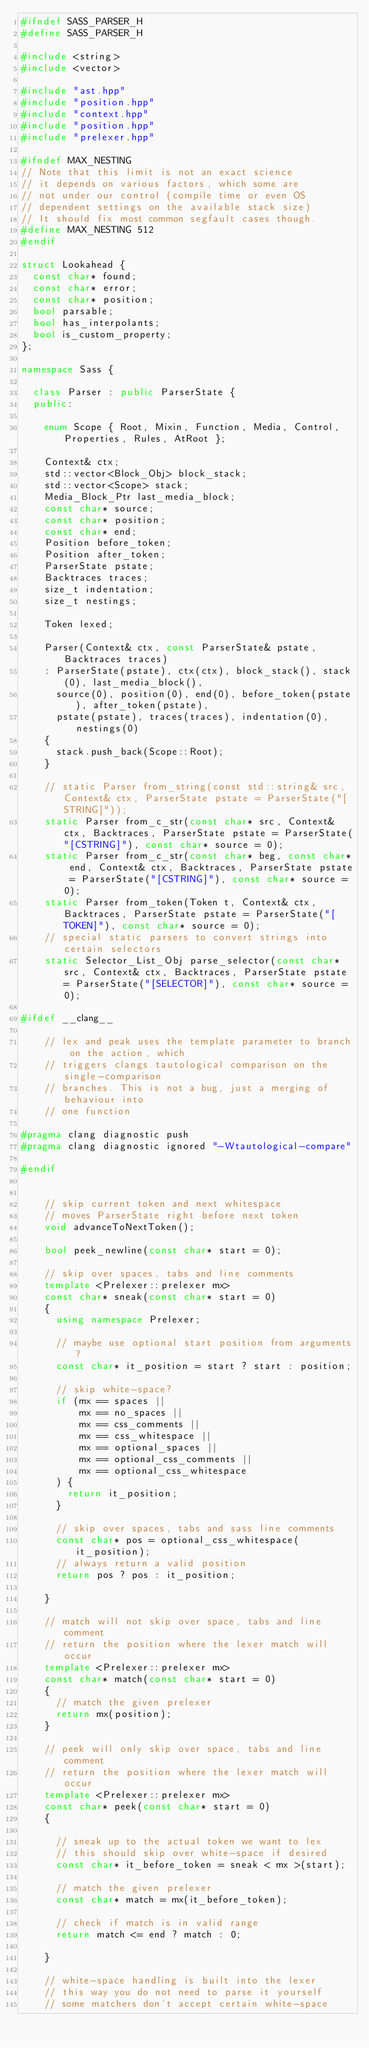Convert code to text. <code><loc_0><loc_0><loc_500><loc_500><_C++_>#ifndef SASS_PARSER_H
#define SASS_PARSER_H

#include <string>
#include <vector>

#include "ast.hpp"
#include "position.hpp"
#include "context.hpp"
#include "position.hpp"
#include "prelexer.hpp"

#ifndef MAX_NESTING
// Note that this limit is not an exact science
// it depends on various factors, which some are
// not under our control (compile time or even OS
// dependent settings on the available stack size)
// It should fix most common segfault cases though.
#define MAX_NESTING 512
#endif

struct Lookahead {
  const char* found;
  const char* error;
  const char* position;
  bool parsable;
  bool has_interpolants;
  bool is_custom_property;
};

namespace Sass {

  class Parser : public ParserState {
  public:

    enum Scope { Root, Mixin, Function, Media, Control, Properties, Rules, AtRoot };

    Context& ctx;
    std::vector<Block_Obj> block_stack;
    std::vector<Scope> stack;
    Media_Block_Ptr last_media_block;
    const char* source;
    const char* position;
    const char* end;
    Position before_token;
    Position after_token;
    ParserState pstate;
    Backtraces traces;
    size_t indentation;
    size_t nestings;

    Token lexed;

    Parser(Context& ctx, const ParserState& pstate, Backtraces traces)
    : ParserState(pstate), ctx(ctx), block_stack(), stack(0), last_media_block(),
      source(0), position(0), end(0), before_token(pstate), after_token(pstate),
      pstate(pstate), traces(traces), indentation(0), nestings(0)
    { 
      stack.push_back(Scope::Root);
    }

    // static Parser from_string(const std::string& src, Context& ctx, ParserState pstate = ParserState("[STRING]"));
    static Parser from_c_str(const char* src, Context& ctx, Backtraces, ParserState pstate = ParserState("[CSTRING]"), const char* source = 0);
    static Parser from_c_str(const char* beg, const char* end, Context& ctx, Backtraces, ParserState pstate = ParserState("[CSTRING]"), const char* source = 0);
    static Parser from_token(Token t, Context& ctx, Backtraces, ParserState pstate = ParserState("[TOKEN]"), const char* source = 0);
    // special static parsers to convert strings into certain selectors
    static Selector_List_Obj parse_selector(const char* src, Context& ctx, Backtraces, ParserState pstate = ParserState("[SELECTOR]"), const char* source = 0);

#ifdef __clang__

    // lex and peak uses the template parameter to branch on the action, which
    // triggers clangs tautological comparison on the single-comparison
    // branches. This is not a bug, just a merging of behaviour into
    // one function

#pragma clang diagnostic push
#pragma clang diagnostic ignored "-Wtautological-compare"

#endif


    // skip current token and next whitespace
    // moves ParserState right before next token
    void advanceToNextToken();

    bool peek_newline(const char* start = 0);

    // skip over spaces, tabs and line comments
    template <Prelexer::prelexer mx>
    const char* sneak(const char* start = 0)
    {
      using namespace Prelexer;

      // maybe use optional start position from arguments?
      const char* it_position = start ? start : position;

      // skip white-space?
      if (mx == spaces ||
          mx == no_spaces ||
          mx == css_comments ||
          mx == css_whitespace ||
          mx == optional_spaces ||
          mx == optional_css_comments ||
          mx == optional_css_whitespace
      ) {
        return it_position;
      }

      // skip over spaces, tabs and sass line comments
      const char* pos = optional_css_whitespace(it_position);
      // always return a valid position
      return pos ? pos : it_position;

    }

    // match will not skip over space, tabs and line comment
    // return the position where the lexer match will occur
    template <Prelexer::prelexer mx>
    const char* match(const char* start = 0)
    {
      // match the given prelexer
      return mx(position);
    }

    // peek will only skip over space, tabs and line comment
    // return the position where the lexer match will occur
    template <Prelexer::prelexer mx>
    const char* peek(const char* start = 0)
    {

      // sneak up to the actual token we want to lex
      // this should skip over white-space if desired
      const char* it_before_token = sneak < mx >(start);

      // match the given prelexer
      const char* match = mx(it_before_token);

      // check if match is in valid range
      return match <= end ? match : 0;

    }

    // white-space handling is built into the lexer
    // this way you do not need to parse it yourself
    // some matchers don't accept certain white-space</code> 